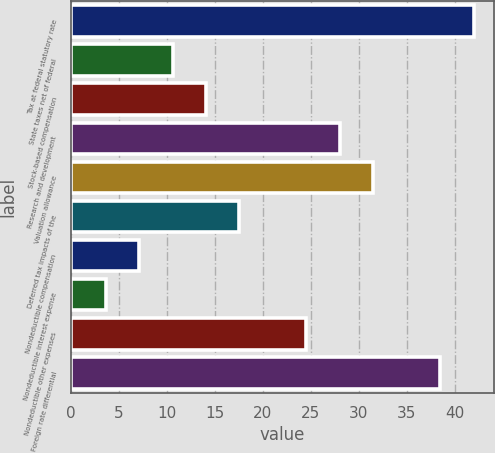<chart> <loc_0><loc_0><loc_500><loc_500><bar_chart><fcel>Tax at federal statutory rate<fcel>State taxes net of federal<fcel>Stock-based compensation<fcel>Research and development<fcel>Valuation allowance<fcel>Deferred tax impacts of the<fcel>Nondeductible compensation<fcel>Nondeductible interest expense<fcel>Nondeductible other expenses<fcel>Foreign rate differential<nl><fcel>41.98<fcel>10.57<fcel>14.06<fcel>28.02<fcel>31.51<fcel>17.55<fcel>7.08<fcel>3.59<fcel>24.53<fcel>38.49<nl></chart> 